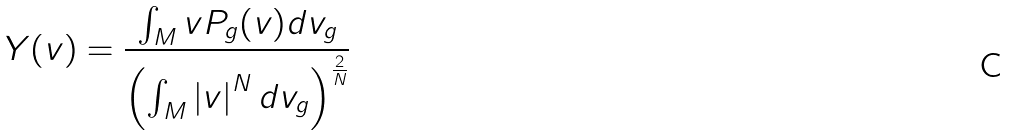Convert formula to latex. <formula><loc_0><loc_0><loc_500><loc_500>Y ( v ) = \frac { \int _ { M } v P _ { g } ( v ) d v _ { g } } { \left ( \int _ { M } \left | v \right | ^ { N } d v _ { g } \right ) ^ { \frac { 2 } { N } } }</formula> 